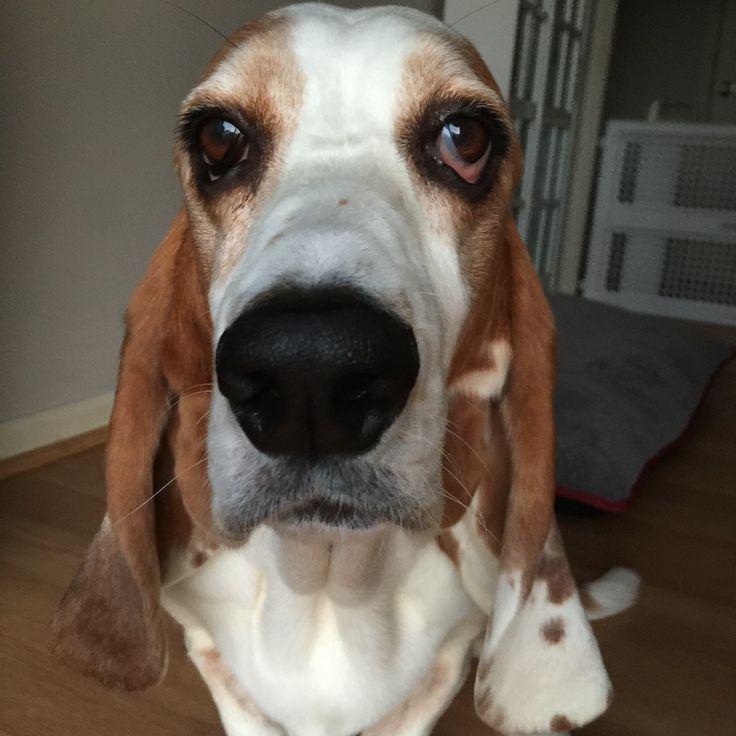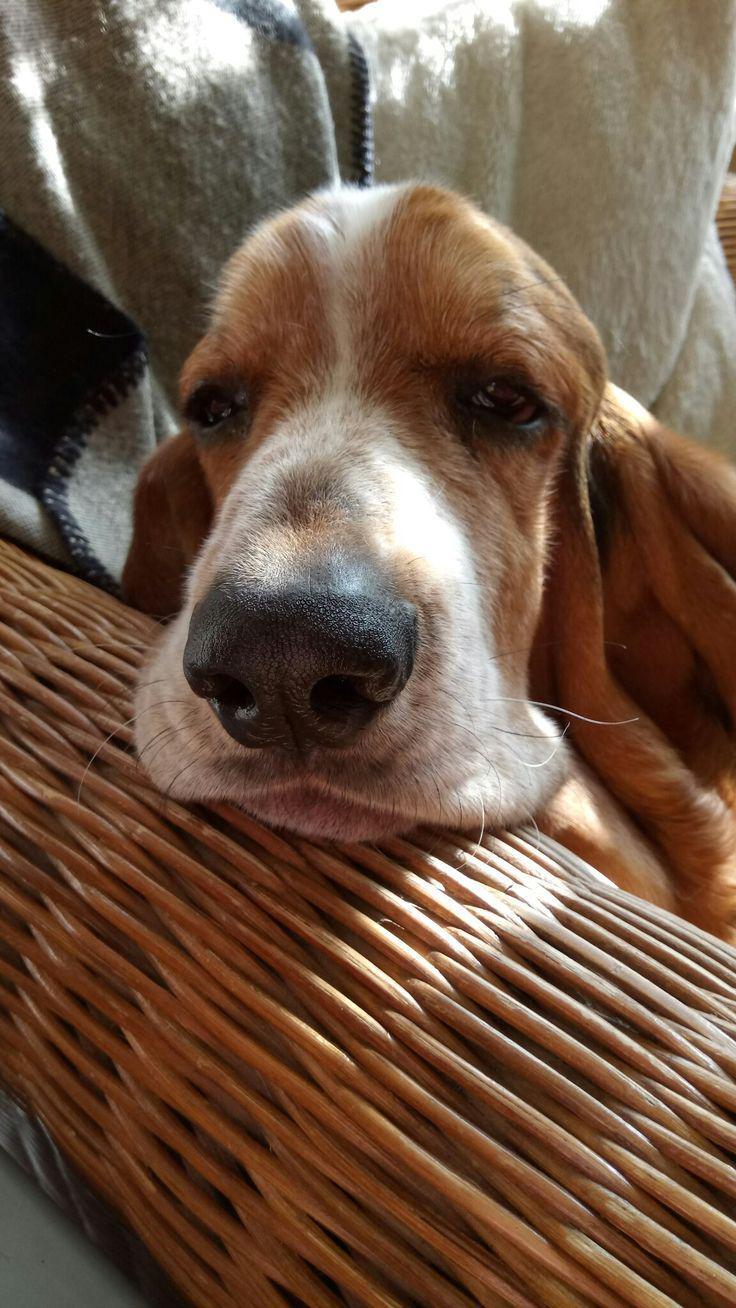The first image is the image on the left, the second image is the image on the right. Evaluate the accuracy of this statement regarding the images: "Each image shows exactly one dog, which is a long-eared hound.". Is it true? Answer yes or no. Yes. 